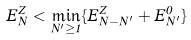Convert formula to latex. <formula><loc_0><loc_0><loc_500><loc_500>E _ { N } ^ { Z } < \min _ { N ^ { \prime } \geq 1 } \{ E _ { N - N ^ { \prime } } ^ { Z } + E _ { N ^ { \prime } } ^ { 0 } \}</formula> 